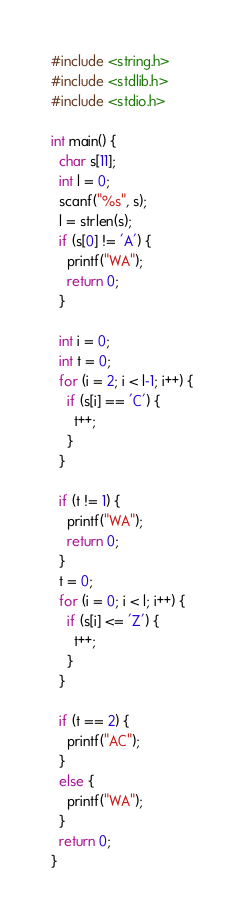<code> <loc_0><loc_0><loc_500><loc_500><_C_>#include <string.h>
#include <stdlib.h>
#include <stdio.h>
 
int main() {
  char s[11];
  int l = 0;
  scanf("%s", s);
  l = strlen(s);
  if (s[0] != 'A') {
    printf("WA");
    return 0;
  }
 
  int i = 0;
  int t = 0;
  for (i = 2; i < l-1; i++) {
    if (s[i] == 'C') {
      t++;
    }
  }
 
  if (t != 1) {
    printf("WA");
    return 0;
  }
  t = 0;
  for (i = 0; i < l; i++) {
    if (s[i] <= 'Z') {
      t++;
    }
  }
 
  if (t == 2) {
    printf("AC");
  }
  else {
    printf("WA");
  }
  return 0;
}</code> 